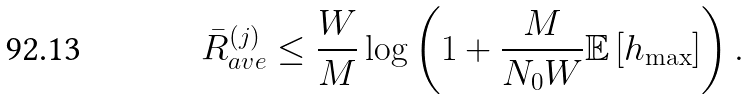<formula> <loc_0><loc_0><loc_500><loc_500>\bar { R } _ { a v e } ^ { ( j ) } \leq \frac { W } { M } \log \left ( 1 + \frac { M } { N _ { 0 } W } \mathbb { E } \left [ h _ { \max } \right ] \right ) .</formula> 